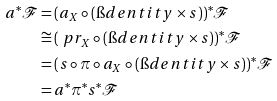<formula> <loc_0><loc_0><loc_500><loc_500>a ^ { * } \mathcal { F } & = ( a _ { X } \circ ( \i d e n t i t y \times s ) ) ^ { * } \mathcal { F } \\ & \cong ( \ p r _ { X } \circ ( \i d e n t i t y \times s ) ) ^ { * } \mathcal { F } \\ & = ( s \circ \pi \circ a _ { X } \circ ( \i d e n t i t y \times s ) ) ^ { * } \mathcal { F } \\ & = a ^ { * } \pi ^ { * } s ^ { * } \mathcal { F }</formula> 